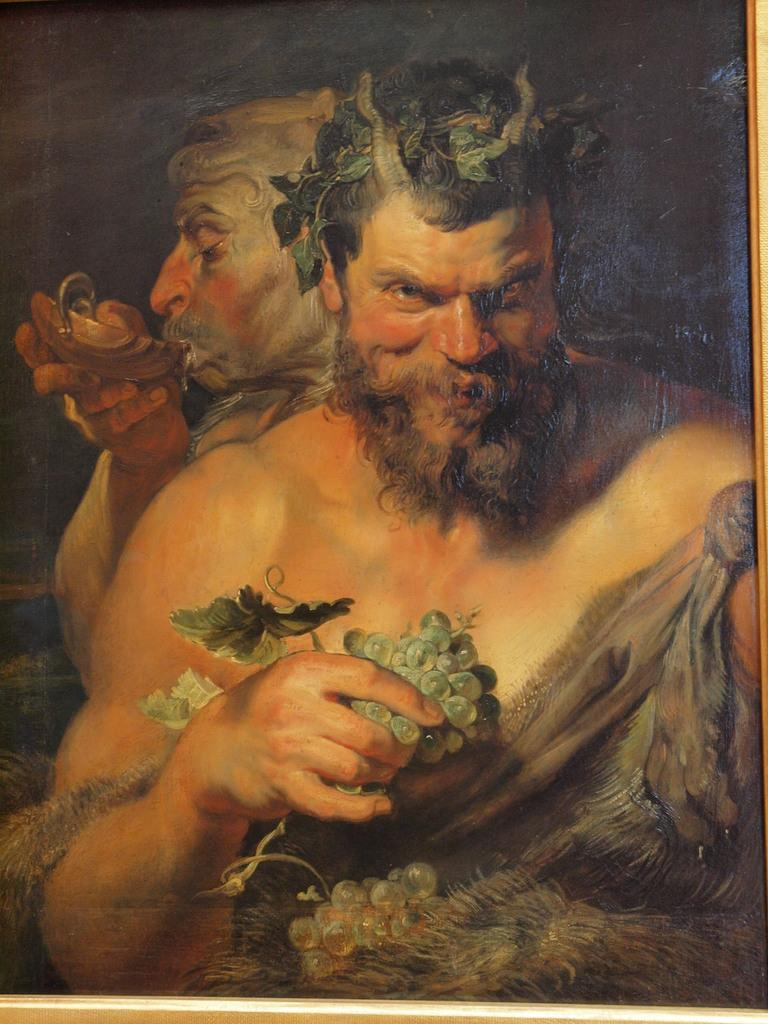What is depicted on the poster in the image? There is a poster with a painting in the image. What are the persons holding in the image? The persons are standing and holding grapes. What is the person at the back doing in the image? The person at the back is holding a bowl and drinking water. How many pigs are present in the image? There are no pigs present in the image. What rule is being enforced by the persons holding grapes in the image? There is no rule being enforced in the image; the persons are simply holding grapes. 